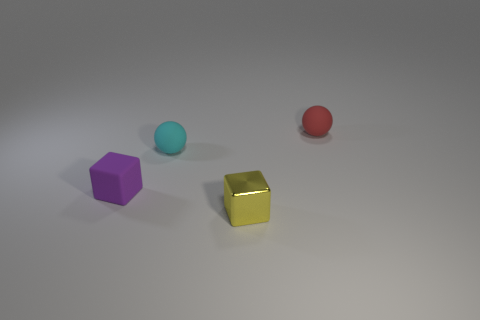Add 3 red balls. How many objects exist? 7 Subtract 1 spheres. How many spheres are left? 1 Subtract all cyan balls. Subtract all yellow cubes. How many balls are left? 1 Subtract all tiny cubes. Subtract all purple matte things. How many objects are left? 1 Add 2 tiny cyan matte balls. How many tiny cyan matte balls are left? 3 Add 1 small rubber objects. How many small rubber objects exist? 4 Subtract 0 purple spheres. How many objects are left? 4 